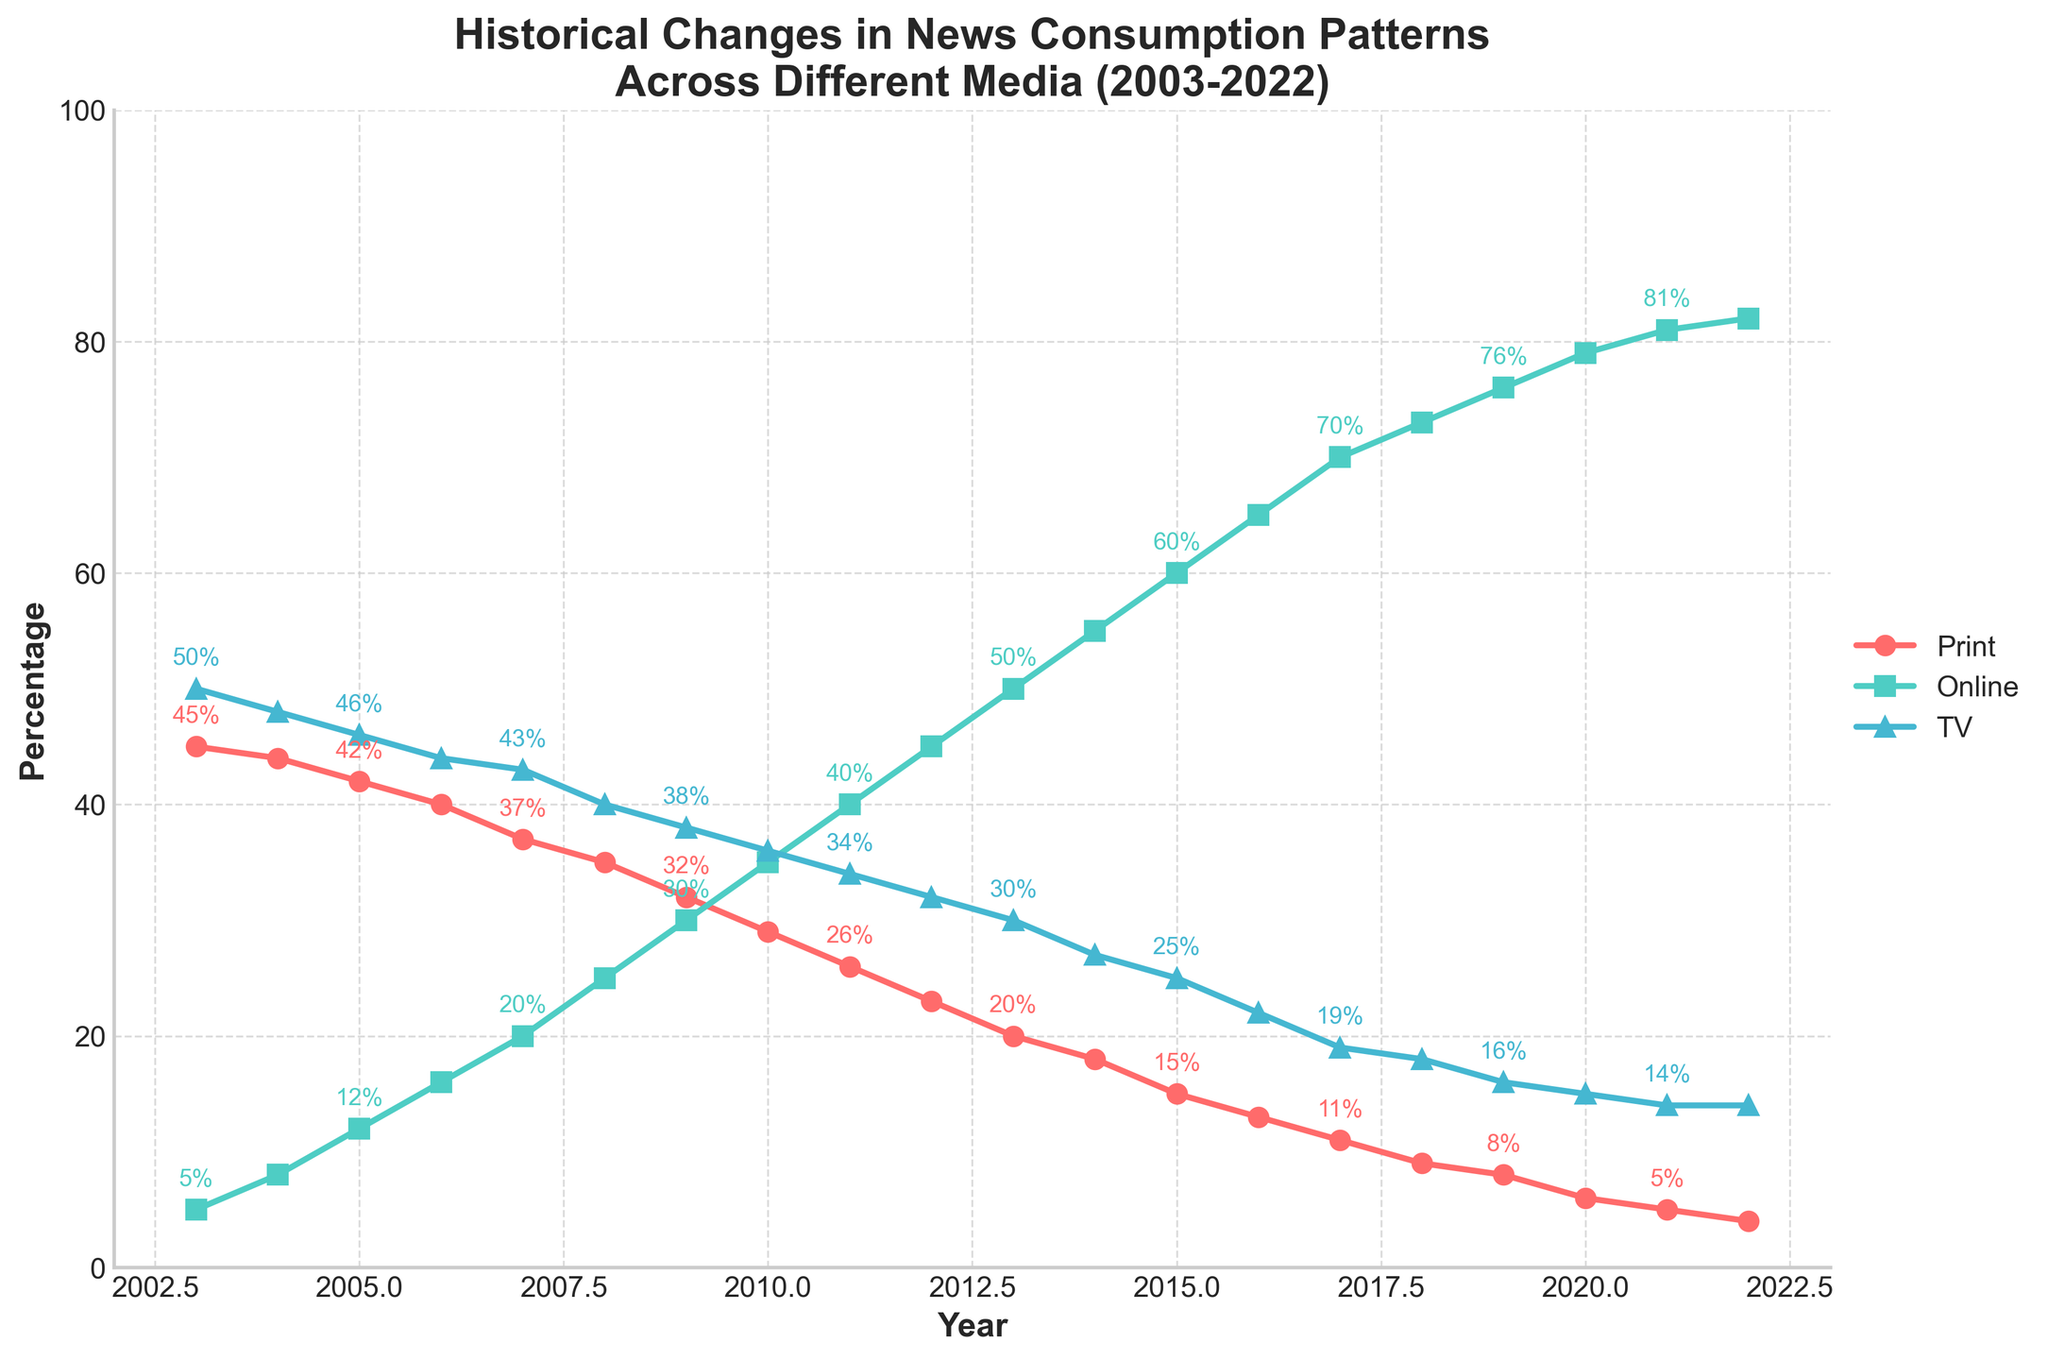What is the title of the plot? The title of the plot is prominently displayed at the top and reads "Historical Changes in News Consumption Patterns Across Different Media (2003-2022)."
Answer: Historical Changes in News Consumption Patterns Across Different Media (2003-2022) How many years are represented in the plot? To determine the number of years, count the data points along the x-axis. The axis starts at 2003 and ends at 2022, which is a span of 20 years.
Answer: 20 What is the general trend for print media consumption over the years? Observing the `Print` line on the plot, it consistently decreases from 45% in 2003 to 4% in 2022. This indicates a declining trend in print media consumption over the 20 years.
Answer: Declining In which year did online media consumption surpass TV consumption? Online media consumption surpassed TV consumption where the `Online` line crosses the `TV` line. This happened between 2007 and 2008. The plot shows Online at 25% and TV at 40% in 2008, indicating the crossing happened around this time.
Answer: Around 2008 Which media type had the highest consumption in 2020? To find the highest consumption in 2020, compare the y-values for Print, Online, and TV lines at the year 2020. Online stands at 79%, TV at 15%, and Print at 6%. Therefore, Online had the highest consumption.
Answer: Online What's the difference in TV media consumption between 2003 and 2022? TV consumption in 2003 was 50%, and in 2022 it was 14%. The difference is calculated as 50% - 14% = 36%.
Answer: 36% What was the percentage of online media consumption in 2015? Locate the `Online` data point for the year 2015, which shows a corresponding percentage value at 60%.
Answer: 60% In which year did print media consumption fall below 10%? Trace the `Print` line to see when it dipped below 10%. By 2017, print consumption stands at 11%, and in 2018, it is at 9%, so it fell below 10% in 2018.
Answer: 2018 Compare the trends of TV and Online media consumption. Which one shows a steady increase, and which one shows a steady decrease? Observing both lines, the `Online` media line consistently rises, indicating a steady increase, whereas the `TV` media line consistently falls, indicating a steady decrease.
Answer: Online increases, TV decreases What is the total percentage of all media consumption types in 2010? To find the total, sum the percentages of Print, Online, and TV for the year 2010. Print is 29%, Online is 35%, and TV is 36%. The total is 29% + 35% + 36% = 100%.
Answer: 100% 